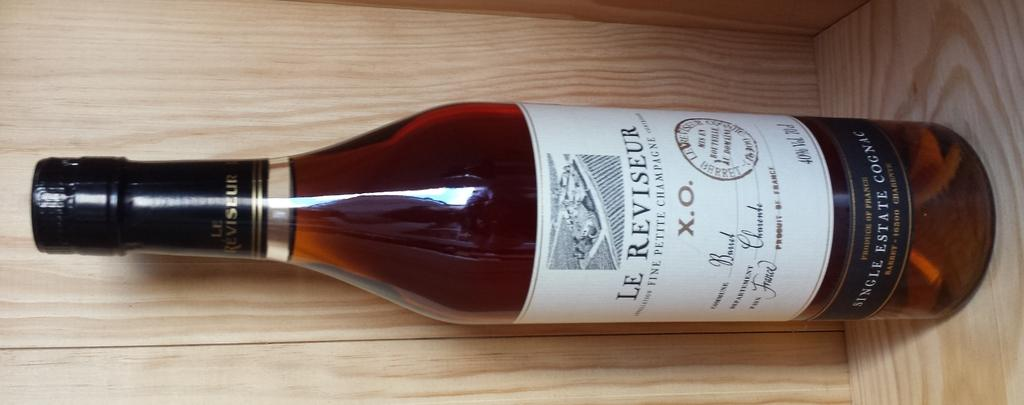<image>
Render a clear and concise summary of the photo. Brown bottle with a white label that says Le Reviseur on it. 